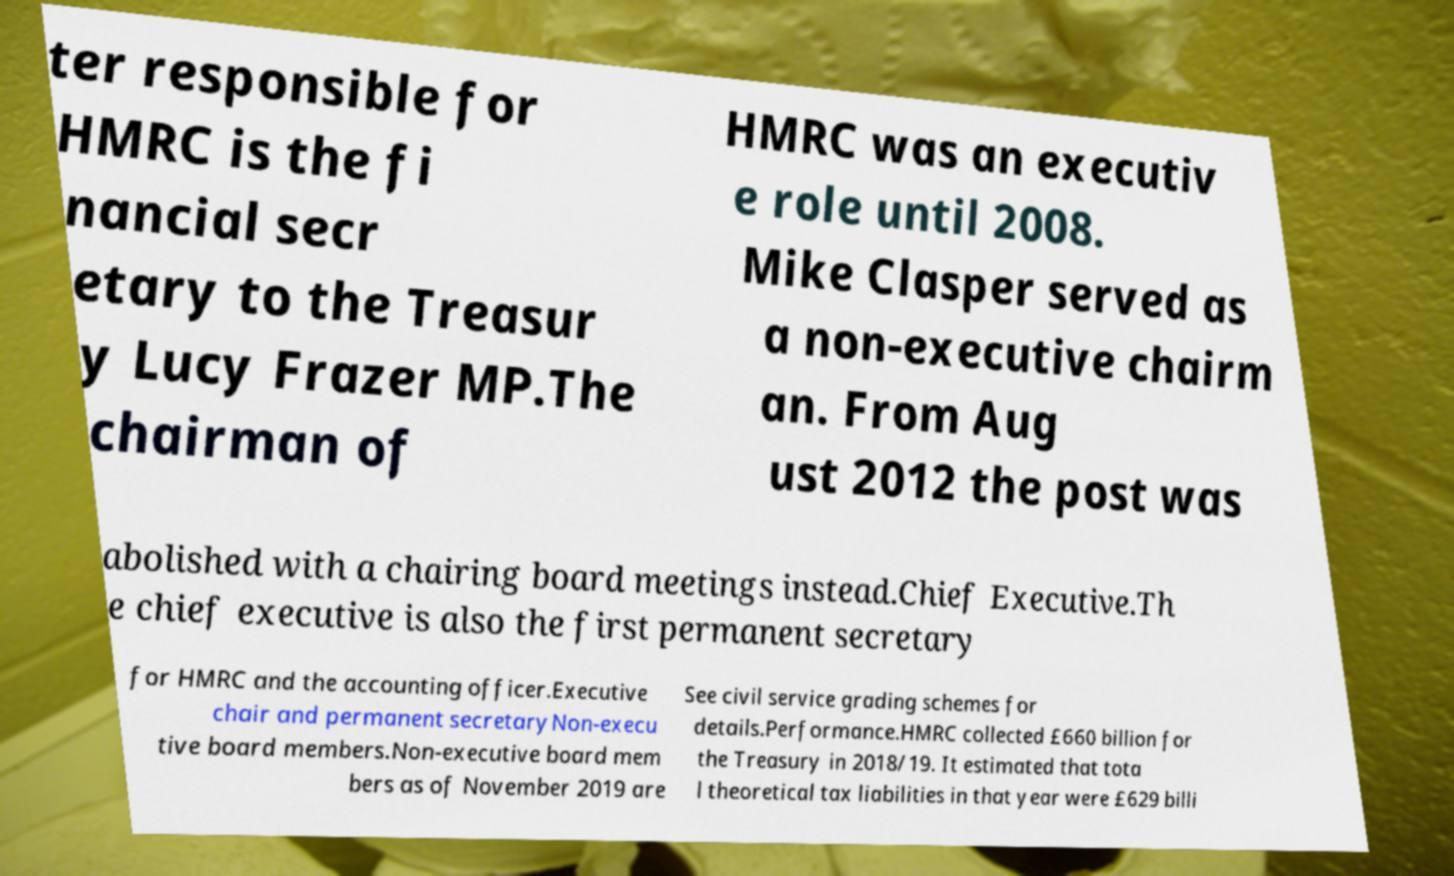Please read and relay the text visible in this image. What does it say? ter responsible for HMRC is the fi nancial secr etary to the Treasur y Lucy Frazer MP.The chairman of HMRC was an executiv e role until 2008. Mike Clasper served as a non-executive chairm an. From Aug ust 2012 the post was abolished with a chairing board meetings instead.Chief Executive.Th e chief executive is also the first permanent secretary for HMRC and the accounting officer.Executive chair and permanent secretaryNon-execu tive board members.Non-executive board mem bers as of November 2019 are See civil service grading schemes for details.Performance.HMRC collected £660 billion for the Treasury in 2018/19. It estimated that tota l theoretical tax liabilities in that year were £629 billi 